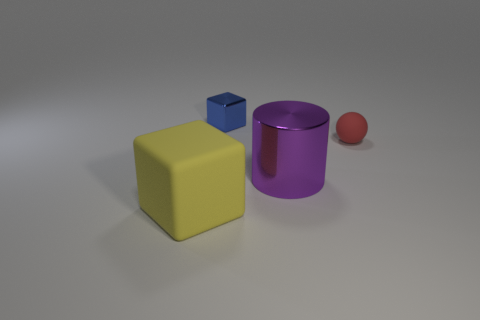Add 4 purple objects. How many objects exist? 8 Subtract all cylinders. How many objects are left? 3 Add 3 blocks. How many blocks exist? 5 Subtract 0 brown spheres. How many objects are left? 4 Subtract all tiny blue cubes. Subtract all cyan shiny cylinders. How many objects are left? 3 Add 4 red spheres. How many red spheres are left? 5 